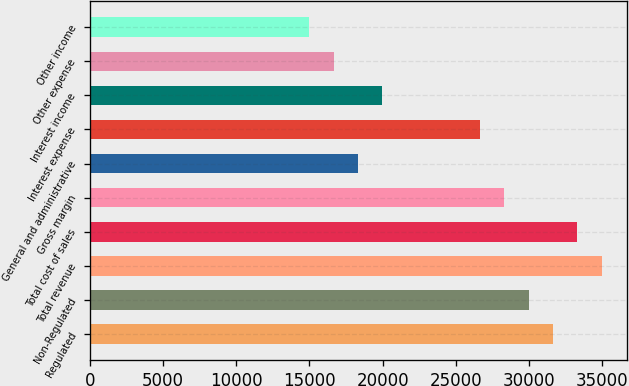Convert chart to OTSL. <chart><loc_0><loc_0><loc_500><loc_500><bar_chart><fcel>Regulated<fcel>Non-Regulated<fcel>Total revenue<fcel>Total cost of sales<fcel>Gross margin<fcel>General and administrative<fcel>Interest expense<fcel>Interest income<fcel>Other expense<fcel>Other income<nl><fcel>31629.3<fcel>29964.6<fcel>34958.7<fcel>33294<fcel>28299.9<fcel>18311.7<fcel>26635.2<fcel>19976.4<fcel>16647<fcel>14982.3<nl></chart> 